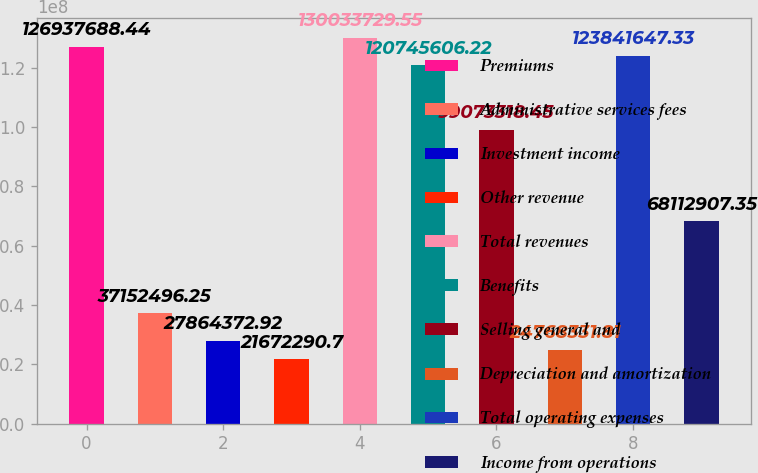<chart> <loc_0><loc_0><loc_500><loc_500><bar_chart><fcel>Premiums<fcel>Administrative services fees<fcel>Investment income<fcel>Other revenue<fcel>Total revenues<fcel>Benefits<fcel>Selling general and<fcel>Depreciation and amortization<fcel>Total operating expenses<fcel>Income from operations<nl><fcel>1.26938e+08<fcel>3.71525e+07<fcel>2.78644e+07<fcel>2.16723e+07<fcel>1.30034e+08<fcel>1.20746e+08<fcel>9.90733e+07<fcel>2.47683e+07<fcel>1.23842e+08<fcel>6.81129e+07<nl></chart> 